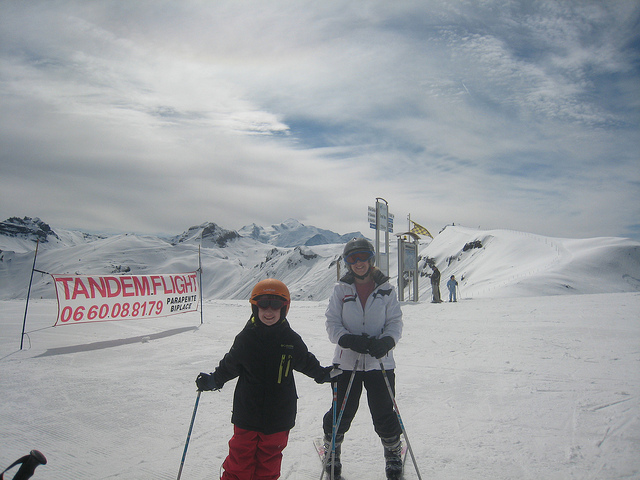Identify and read out the text in this image. TANDEM FLIGHT 0660.08.81.79 PARAFE BIPLACE 